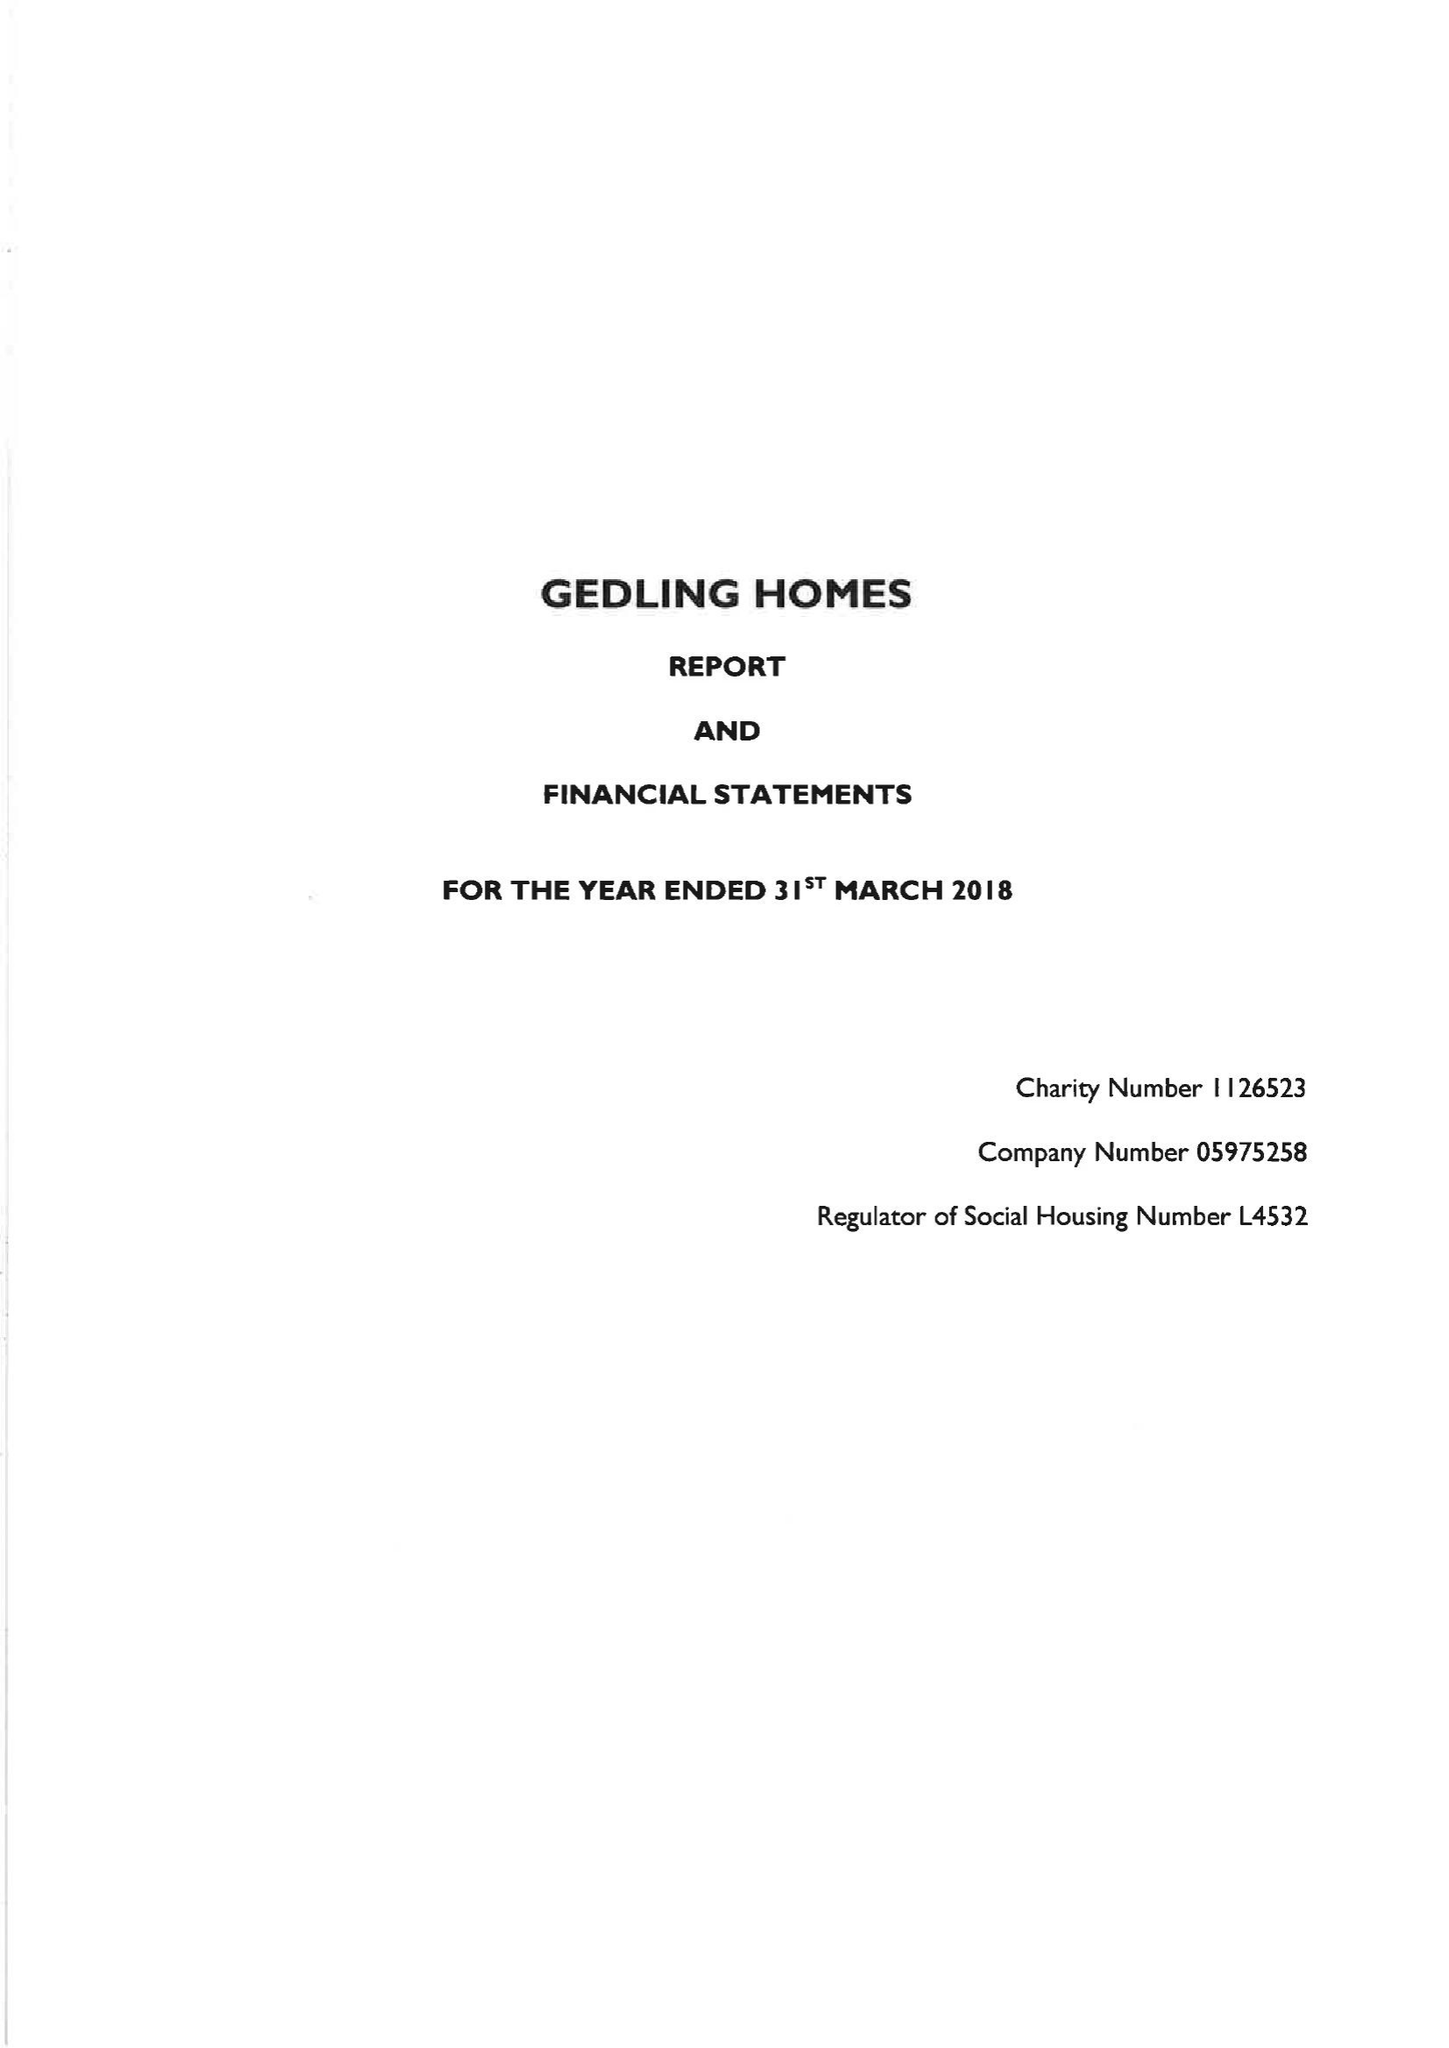What is the value for the charity_number?
Answer the question using a single word or phrase. 1126523 